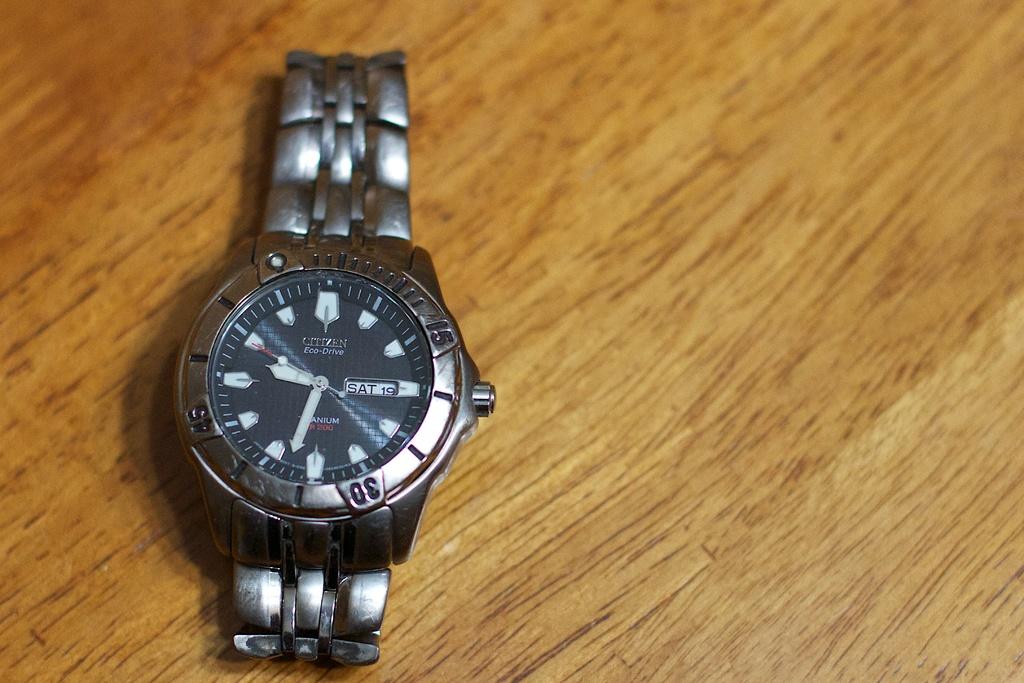What time is it?
Give a very brief answer. 9:34. What brand of watch is this?
Your answer should be very brief. Citizen. 